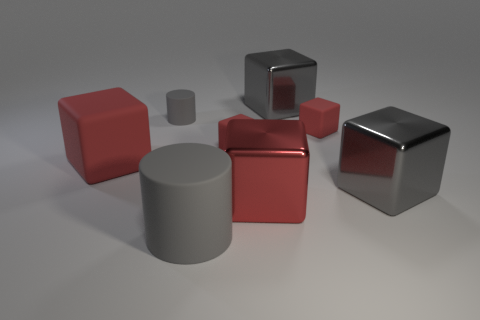Subtract all purple cylinders. How many red cubes are left? 4 Subtract 2 cubes. How many cubes are left? 4 Subtract all big gray cubes. How many cubes are left? 4 Subtract all gray blocks. How many blocks are left? 4 Subtract all yellow cubes. Subtract all green cylinders. How many cubes are left? 6 Add 1 red metallic cubes. How many objects exist? 9 Subtract all cylinders. How many objects are left? 6 Add 8 large rubber things. How many large rubber things exist? 10 Subtract 2 gray cylinders. How many objects are left? 6 Subtract all red cylinders. Subtract all large rubber cylinders. How many objects are left? 7 